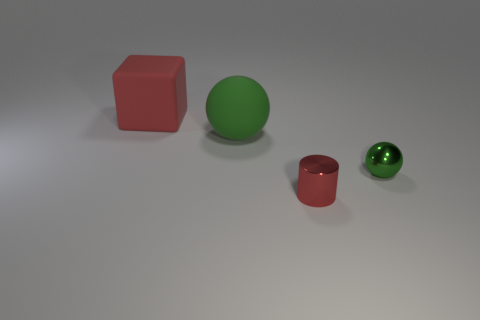Add 2 red cubes. How many objects exist? 6 Subtract all cubes. How many objects are left? 3 Subtract 0 purple blocks. How many objects are left? 4 Subtract all large brown rubber cubes. Subtract all big rubber objects. How many objects are left? 2 Add 4 big cubes. How many big cubes are left? 5 Add 1 red metallic things. How many red metallic things exist? 2 